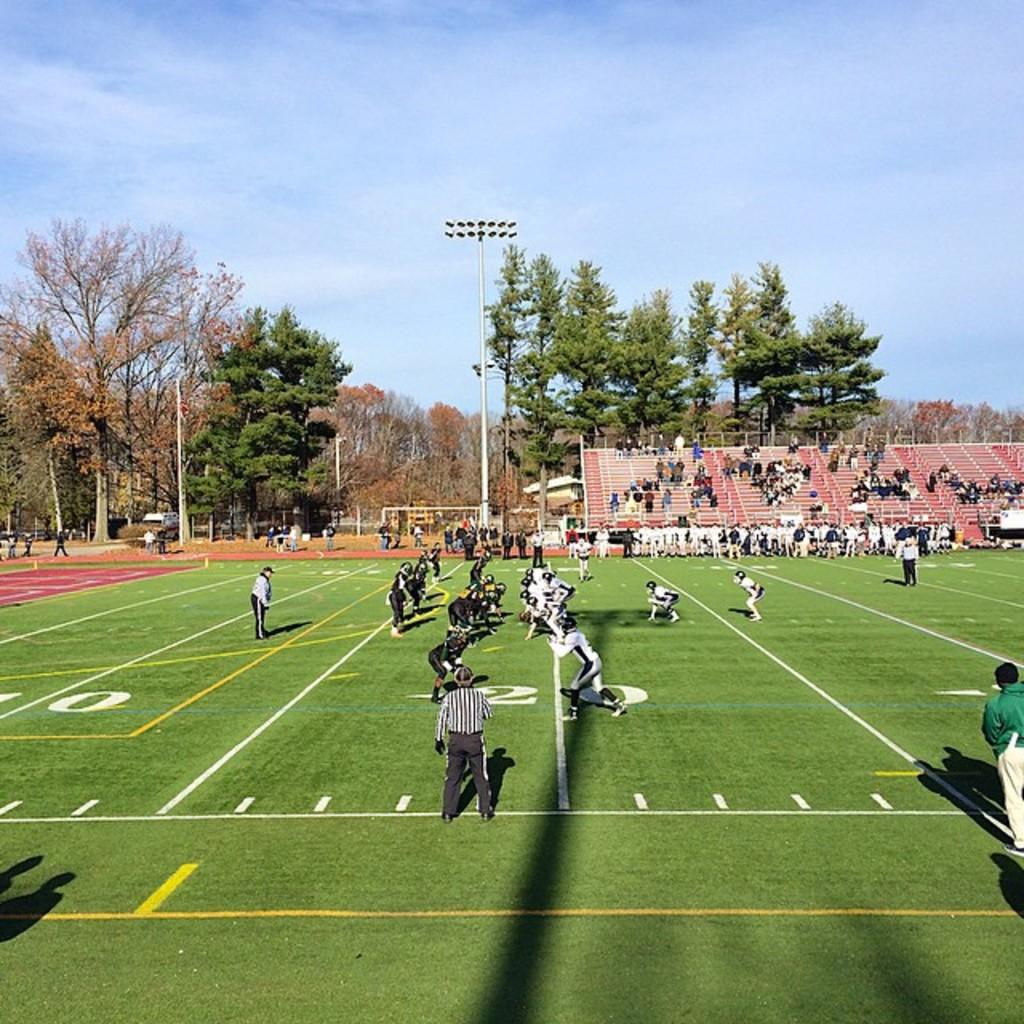What is happening on the ground in the image? There are players on the ground in the image. Can you describe any architectural features in the image? Yes, there are stairs visible in the image. What type of natural elements can be seen in the image? There are trees in the image. What is the color of the sky in the image? The sky is blue and white in color. Is there any man-made structure visible in the image? Yes, there is a light pole in the image. What type of straw is being used by the players in the image? There is no straw present in the image; the players are not using any straws. How does the tub affect the feeling of the players in the image? There is no tub present in the image, so it cannot affect the players' feelings. 